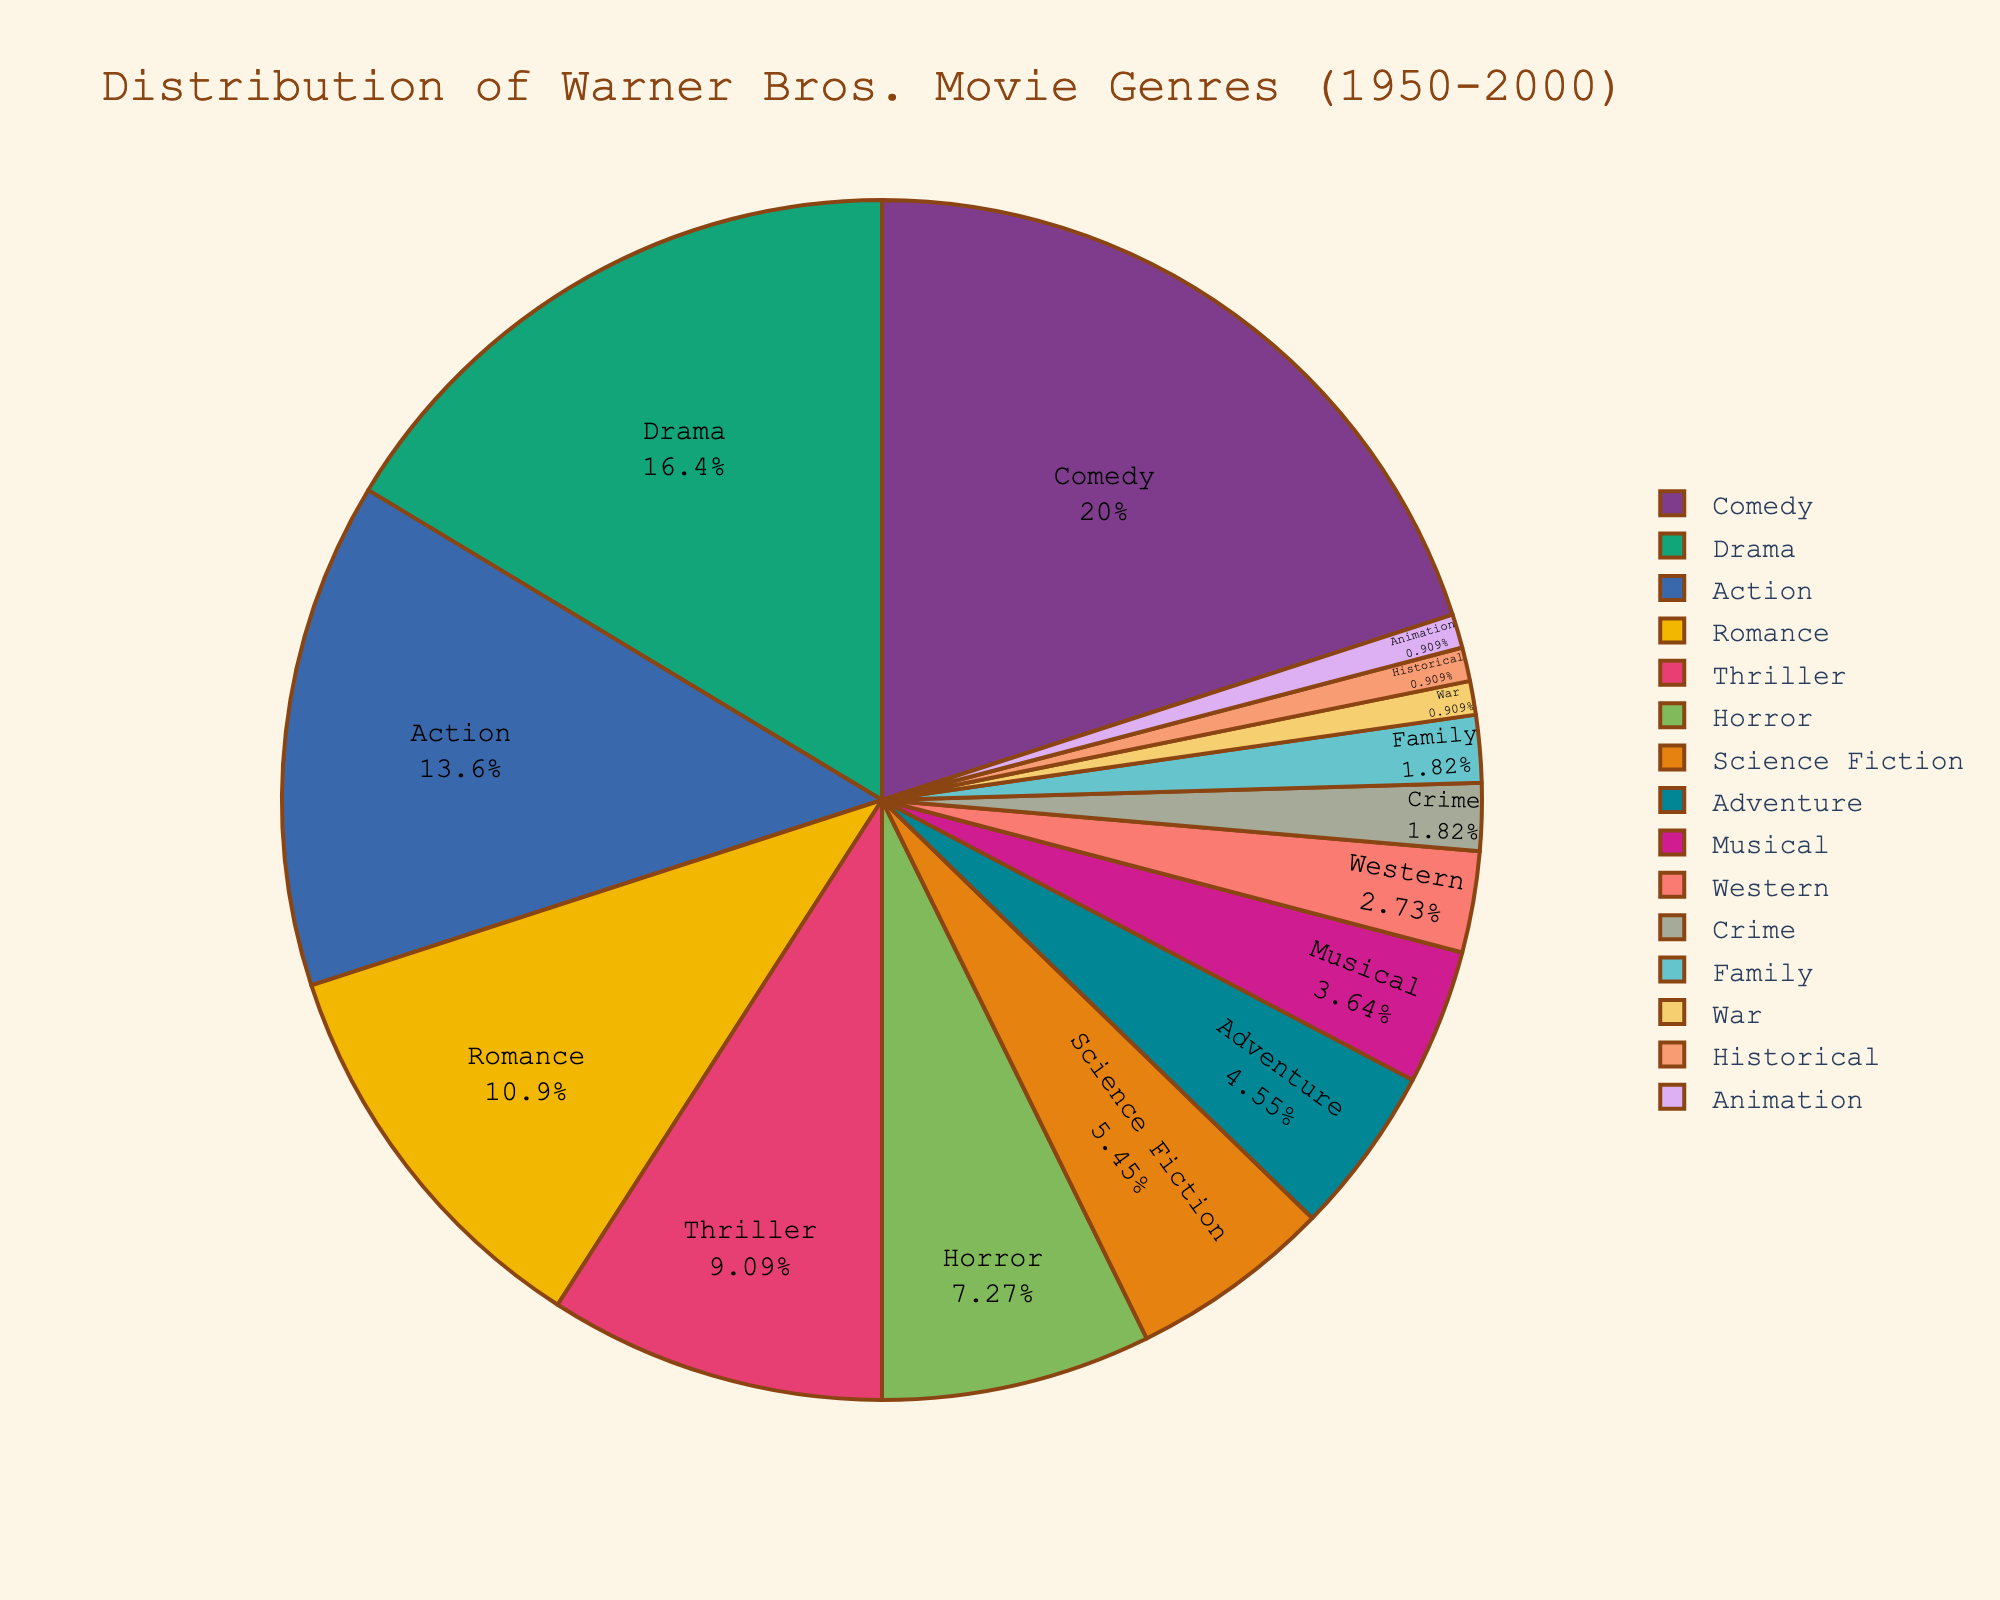What genre comprises the largest percentage of Warner Bros. movies? The pie chart shows that Comedy takes up the largest slice, which is 22%.
Answer: Comedy Which genre has the smallest representation in Warner Bros. movies? The smallest slice in the pie chart, representing 1%, corresponds to Historical, War, and Animation genres.
Answer: Historical, War, Animation How does the percentage of Action movies compare to Drama movies in the chart? The percentage of Action movies is 15%, whereas Drama movies make up 18%. Comparing the two, Drama movies exceed Action movies by 3%.
Answer: Drama is 3% more than Action What is the combined percentage of Family and Crime movies? From the chart, Family movies make up 2% and Crime movies also contribute 2%. Adding these together, the total percentage is 2% + 2% = 4%.
Answer: 4% By how much does the percentage of Comedy movies exceed the percentage of Romance movies? Comedy movies constitute 22% and Romance movies make up 12%. The difference is calculated as 22% - 12% = 10%.
Answer: 10% What percentage of the movie genres does not fall under the top five categories (Comedy, Drama, Action, Romance, Thriller)? The percentages for the top five categories are: 22% (Comedy) + 18% (Drama) + 15% (Action) + 12% (Romance) + 10% (Thriller) = 77%. The remaining percentage is 100% - 77% = 23%.
Answer: 23% Which genre has a greater percentage, Science Fiction or Horror? According to the chart, Horror accounts for 8%, while Science Fiction represents 6%. Therefore, Horror has a greater percentage than Science Fiction.
Answer: Horror What is the total percentage of genres related to action and adventure combined? The chart shows Action at 15% and Adventure at 5%. Adding these together, 15% + 5% = 20%.
Answer: 20% Is the percentage for Western movies greater or less than that for Musical movies? Western movies account for 3%, whereas Musical movies make up 4%. Western is less than Musical by 1%.
Answer: Less What is the cumulative percentage of genres accounting for 2% each? The genres that account for 2% each are Crime and Family. Summing these up gives 2% + 2% = 4%.
Answer: 4% 